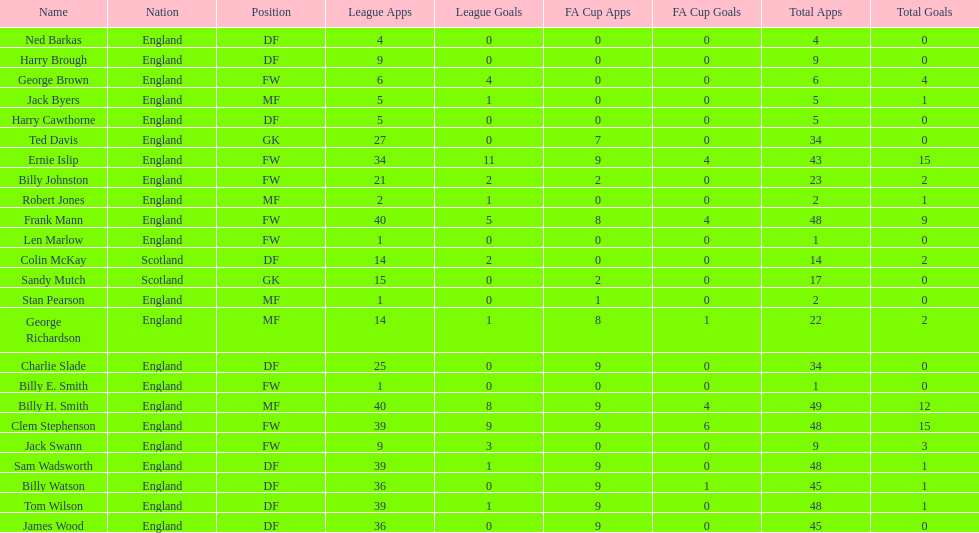What is the last name listed on this chart? James Wood. 